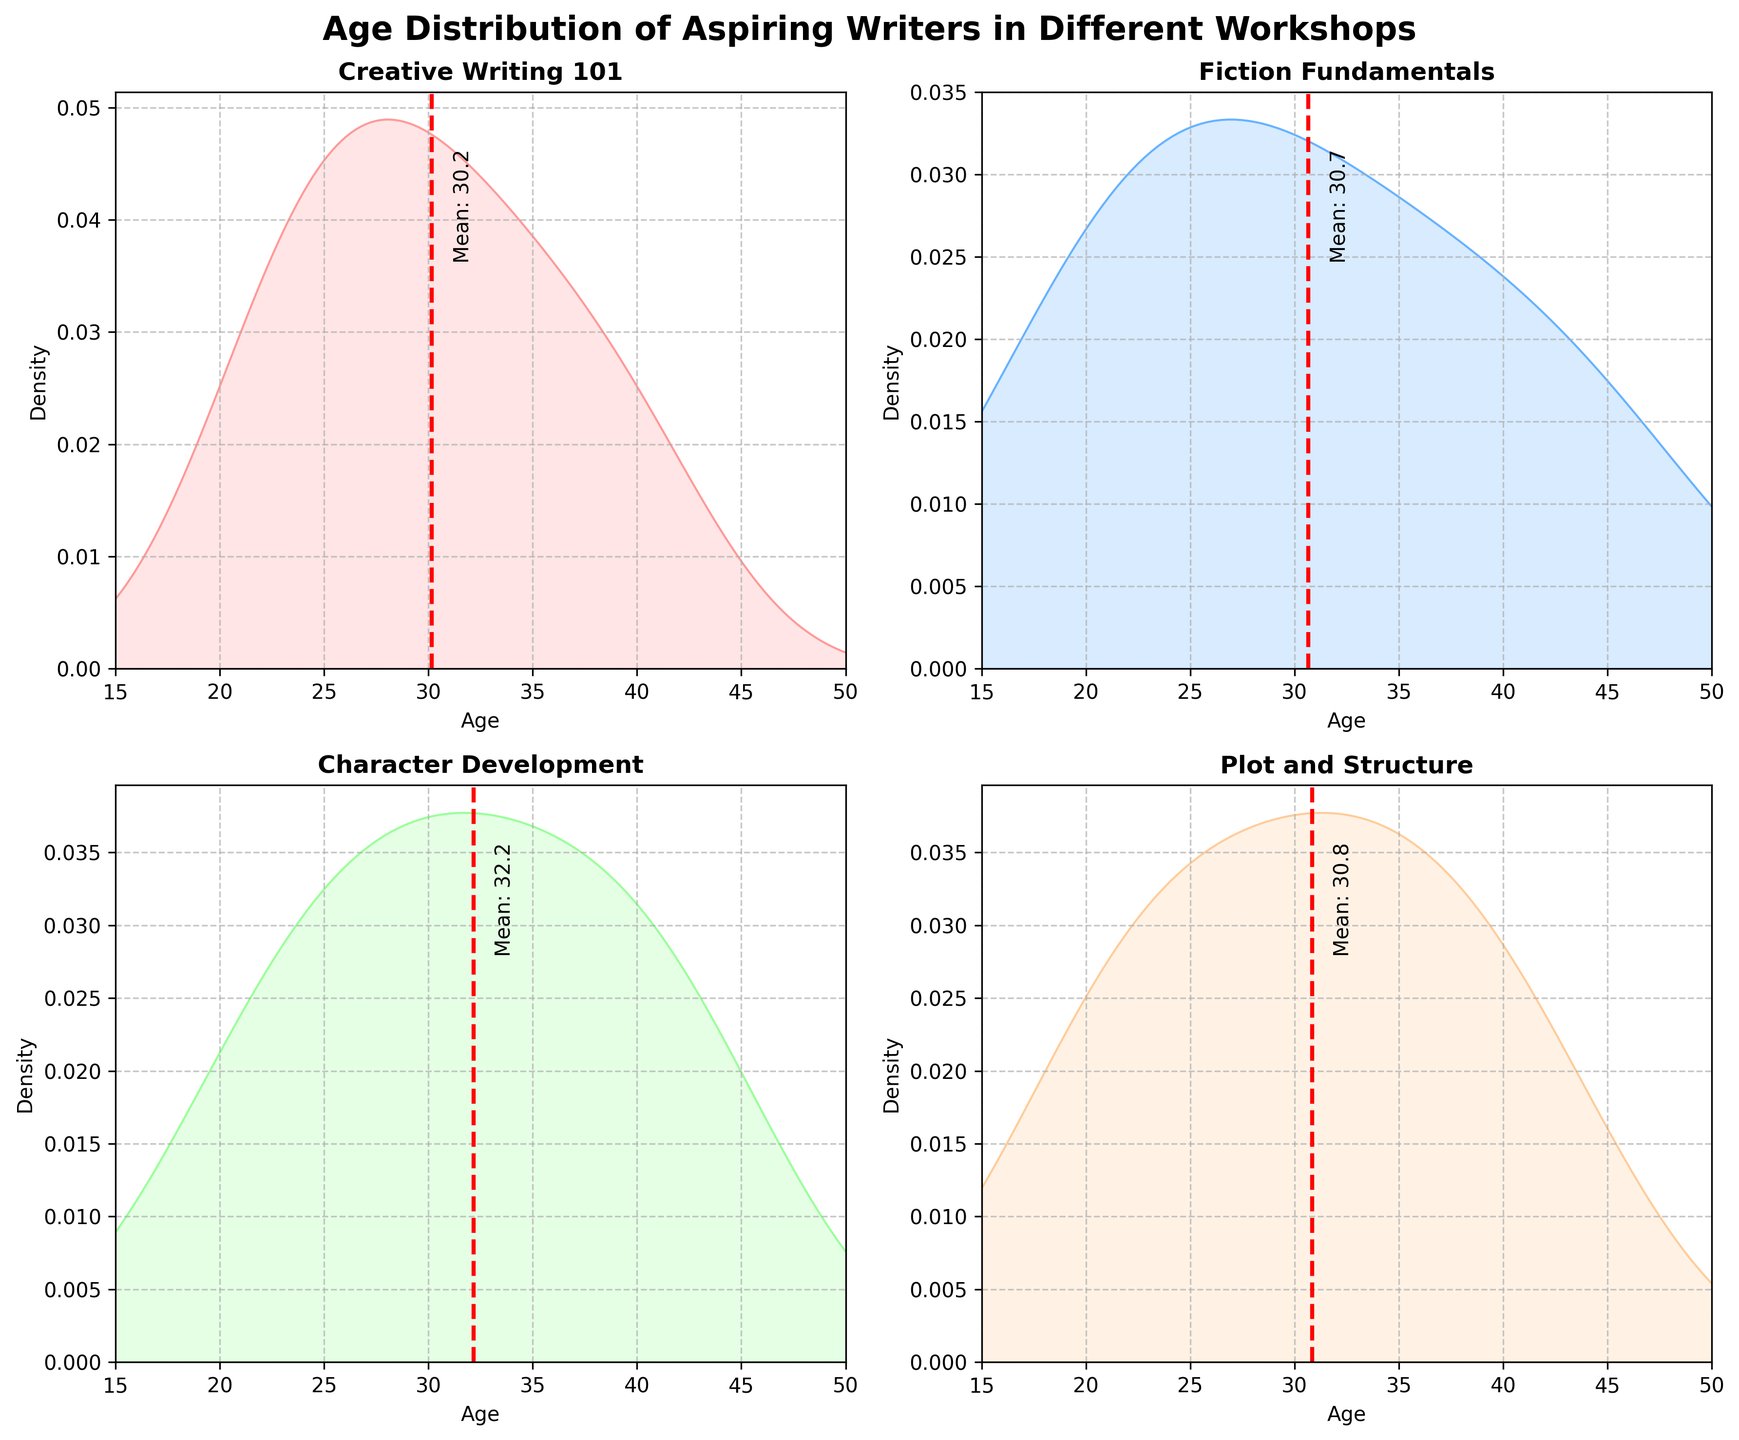What's the title of the figure? The title of the figure is typically located at the top and summarizes what the plots represent. Here, the title is "Age Distribution of Aspiring Writers in Different Workshops".
Answer: Age Distribution of Aspiring Writers in Different Workshops How many subplots are there in the figure? The figure is divided into multiple smaller plots called subplots. By counting the individual plots, we see that there are four in the figure.
Answer: 4 Which workshop has the highest peak density? By observing the peaks of the density plots in each subplot, the workshop with the highest peak is identified. The subplot for "Plot and Structure" has the highest peak density.
Answer: Plot and Structure What is the mean age of participants in the 'Character Development' workshop? Each subplot includes a dashed vertical line representing the mean age. For the "Character Development" workshop, the mean age line is labeled around 32.2.
Answer: 32.2 Which workshop has the least varied age distribution? The variation in age distribution can be observed by the spread of the density plot. The narrower the plot, the less varied the distribution. "Creative Writing 101" appears to have the least variation.
Answer: Creative Writing 101 Is there any workshop where the mean age line falls above 40? By examining the mean age lines across all subplots, it's noted that the mean age line in the "Fiction Fundamentals" workshop is above 40.
Answer: Fiction Fundamentals How does the age distribution of 'Fiction Fundamentals' compare to 'Creative Writing 101'? Comparing the spread and peak densities of both workshops, "Fiction Fundamentals" shows a broader range with a peak at an older age, while "Creative Writing 101" has a tighter distribution around a younger age.
Answer: 'Fiction Fundamentals' shows a broader range with an older peak, 'Creative Writing 101' has a tighter distribution around a younger age What is the range of ages plotted in the figure? Each subplot has the same x-axis range, which can be determined by looking at the axis labels. The age range displayed on all subplots is from 15 to 50.
Answer: 15 to 50 